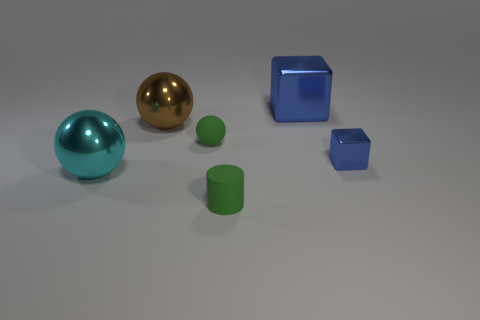Subtract all cyan metal spheres. How many spheres are left? 2 Subtract all green spheres. How many spheres are left? 2 Add 2 big green cylinders. How many objects exist? 8 Subtract all blocks. How many objects are left? 4 Subtract 1 balls. How many balls are left? 2 Subtract all small matte cylinders. Subtract all green spheres. How many objects are left? 4 Add 3 brown things. How many brown things are left? 4 Add 3 big red shiny spheres. How many big red shiny spheres exist? 3 Subtract 0 blue balls. How many objects are left? 6 Subtract all red spheres. Subtract all blue cubes. How many spheres are left? 3 